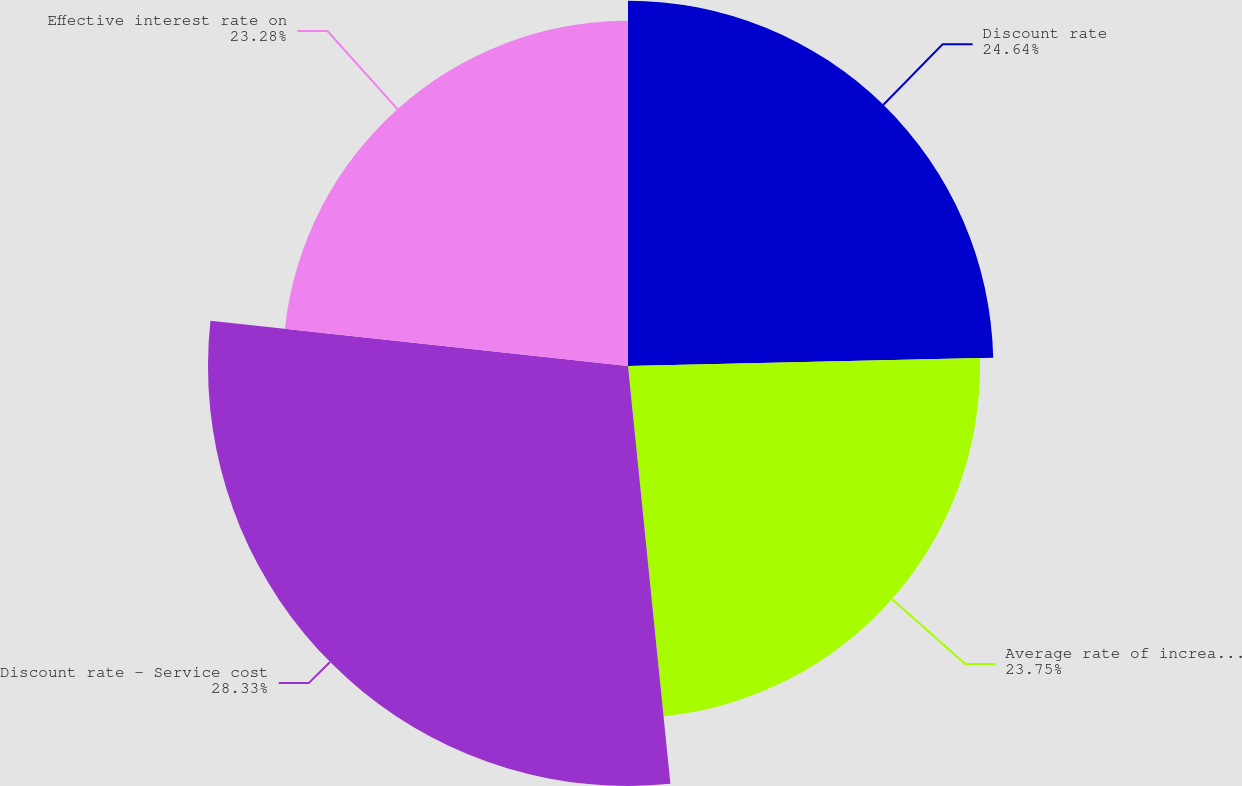Convert chart. <chart><loc_0><loc_0><loc_500><loc_500><pie_chart><fcel>Discount rate<fcel>Average rate of increase in<fcel>Discount rate - Service cost<fcel>Effective interest rate on<nl><fcel>24.64%<fcel>23.75%<fcel>28.33%<fcel>23.28%<nl></chart> 